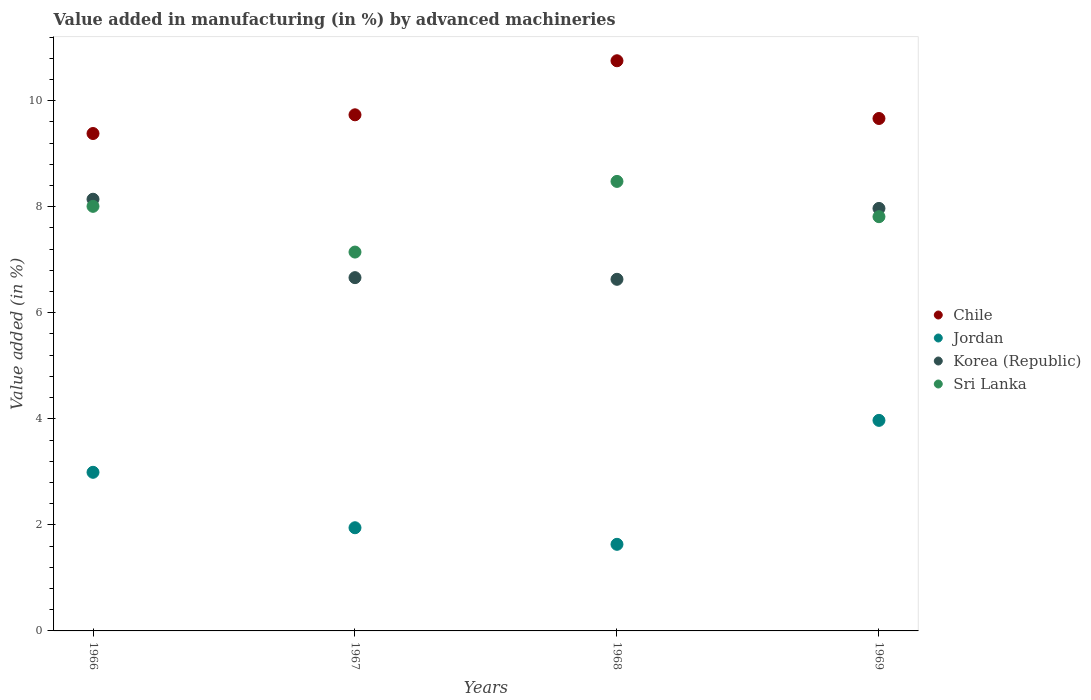Is the number of dotlines equal to the number of legend labels?
Provide a succinct answer. Yes. What is the percentage of value added in manufacturing by advanced machineries in Sri Lanka in 1967?
Provide a succinct answer. 7.14. Across all years, what is the maximum percentage of value added in manufacturing by advanced machineries in Korea (Republic)?
Your answer should be very brief. 8.14. Across all years, what is the minimum percentage of value added in manufacturing by advanced machineries in Korea (Republic)?
Your response must be concise. 6.63. In which year was the percentage of value added in manufacturing by advanced machineries in Chile maximum?
Ensure brevity in your answer.  1968. In which year was the percentage of value added in manufacturing by advanced machineries in Sri Lanka minimum?
Keep it short and to the point. 1967. What is the total percentage of value added in manufacturing by advanced machineries in Chile in the graph?
Provide a short and direct response. 39.53. What is the difference between the percentage of value added in manufacturing by advanced machineries in Sri Lanka in 1966 and that in 1968?
Provide a succinct answer. -0.47. What is the difference between the percentage of value added in manufacturing by advanced machineries in Jordan in 1967 and the percentage of value added in manufacturing by advanced machineries in Sri Lanka in 1968?
Keep it short and to the point. -6.53. What is the average percentage of value added in manufacturing by advanced machineries in Korea (Republic) per year?
Offer a terse response. 7.35. In the year 1967, what is the difference between the percentage of value added in manufacturing by advanced machineries in Jordan and percentage of value added in manufacturing by advanced machineries in Sri Lanka?
Provide a succinct answer. -5.2. In how many years, is the percentage of value added in manufacturing by advanced machineries in Chile greater than 4 %?
Offer a terse response. 4. What is the ratio of the percentage of value added in manufacturing by advanced machineries in Korea (Republic) in 1967 to that in 1968?
Keep it short and to the point. 1. Is the percentage of value added in manufacturing by advanced machineries in Sri Lanka in 1967 less than that in 1969?
Your answer should be compact. Yes. What is the difference between the highest and the second highest percentage of value added in manufacturing by advanced machineries in Jordan?
Your response must be concise. 0.98. What is the difference between the highest and the lowest percentage of value added in manufacturing by advanced machineries in Chile?
Ensure brevity in your answer.  1.37. Is it the case that in every year, the sum of the percentage of value added in manufacturing by advanced machineries in Sri Lanka and percentage of value added in manufacturing by advanced machineries in Chile  is greater than the percentage of value added in manufacturing by advanced machineries in Korea (Republic)?
Offer a terse response. Yes. Does the percentage of value added in manufacturing by advanced machineries in Jordan monotonically increase over the years?
Your answer should be very brief. No. Is the percentage of value added in manufacturing by advanced machineries in Jordan strictly greater than the percentage of value added in manufacturing by advanced machineries in Chile over the years?
Provide a succinct answer. No. How many years are there in the graph?
Ensure brevity in your answer.  4. What is the difference between two consecutive major ticks on the Y-axis?
Your answer should be very brief. 2. Are the values on the major ticks of Y-axis written in scientific E-notation?
Keep it short and to the point. No. Does the graph contain grids?
Your response must be concise. No. Where does the legend appear in the graph?
Your response must be concise. Center right. How many legend labels are there?
Offer a terse response. 4. What is the title of the graph?
Your answer should be very brief. Value added in manufacturing (in %) by advanced machineries. What is the label or title of the X-axis?
Offer a very short reply. Years. What is the label or title of the Y-axis?
Offer a very short reply. Value added (in %). What is the Value added (in %) in Chile in 1966?
Your answer should be compact. 9.38. What is the Value added (in %) in Jordan in 1966?
Give a very brief answer. 2.99. What is the Value added (in %) of Korea (Republic) in 1966?
Your answer should be very brief. 8.14. What is the Value added (in %) of Sri Lanka in 1966?
Make the answer very short. 8.01. What is the Value added (in %) in Chile in 1967?
Provide a short and direct response. 9.73. What is the Value added (in %) of Jordan in 1967?
Provide a short and direct response. 1.95. What is the Value added (in %) in Korea (Republic) in 1967?
Your response must be concise. 6.66. What is the Value added (in %) in Sri Lanka in 1967?
Provide a succinct answer. 7.14. What is the Value added (in %) of Chile in 1968?
Ensure brevity in your answer.  10.75. What is the Value added (in %) of Jordan in 1968?
Offer a terse response. 1.63. What is the Value added (in %) of Korea (Republic) in 1968?
Make the answer very short. 6.63. What is the Value added (in %) of Sri Lanka in 1968?
Offer a terse response. 8.48. What is the Value added (in %) in Chile in 1969?
Your answer should be very brief. 9.66. What is the Value added (in %) in Jordan in 1969?
Make the answer very short. 3.97. What is the Value added (in %) in Korea (Republic) in 1969?
Provide a short and direct response. 7.97. What is the Value added (in %) in Sri Lanka in 1969?
Provide a succinct answer. 7.81. Across all years, what is the maximum Value added (in %) of Chile?
Offer a very short reply. 10.75. Across all years, what is the maximum Value added (in %) in Jordan?
Make the answer very short. 3.97. Across all years, what is the maximum Value added (in %) in Korea (Republic)?
Keep it short and to the point. 8.14. Across all years, what is the maximum Value added (in %) in Sri Lanka?
Make the answer very short. 8.48. Across all years, what is the minimum Value added (in %) in Chile?
Offer a very short reply. 9.38. Across all years, what is the minimum Value added (in %) in Jordan?
Your answer should be compact. 1.63. Across all years, what is the minimum Value added (in %) of Korea (Republic)?
Offer a terse response. 6.63. Across all years, what is the minimum Value added (in %) in Sri Lanka?
Give a very brief answer. 7.14. What is the total Value added (in %) of Chile in the graph?
Your response must be concise. 39.53. What is the total Value added (in %) of Jordan in the graph?
Ensure brevity in your answer.  10.54. What is the total Value added (in %) of Korea (Republic) in the graph?
Offer a terse response. 29.4. What is the total Value added (in %) in Sri Lanka in the graph?
Your answer should be compact. 31.44. What is the difference between the Value added (in %) in Chile in 1966 and that in 1967?
Provide a short and direct response. -0.35. What is the difference between the Value added (in %) in Jordan in 1966 and that in 1967?
Offer a terse response. 1.05. What is the difference between the Value added (in %) in Korea (Republic) in 1966 and that in 1967?
Offer a terse response. 1.48. What is the difference between the Value added (in %) in Sri Lanka in 1966 and that in 1967?
Offer a very short reply. 0.86. What is the difference between the Value added (in %) of Chile in 1966 and that in 1968?
Provide a succinct answer. -1.37. What is the difference between the Value added (in %) of Jordan in 1966 and that in 1968?
Your answer should be very brief. 1.36. What is the difference between the Value added (in %) in Korea (Republic) in 1966 and that in 1968?
Make the answer very short. 1.51. What is the difference between the Value added (in %) in Sri Lanka in 1966 and that in 1968?
Give a very brief answer. -0.47. What is the difference between the Value added (in %) in Chile in 1966 and that in 1969?
Offer a very short reply. -0.28. What is the difference between the Value added (in %) of Jordan in 1966 and that in 1969?
Your response must be concise. -0.98. What is the difference between the Value added (in %) in Korea (Republic) in 1966 and that in 1969?
Ensure brevity in your answer.  0.17. What is the difference between the Value added (in %) of Sri Lanka in 1966 and that in 1969?
Offer a very short reply. 0.19. What is the difference between the Value added (in %) in Chile in 1967 and that in 1968?
Offer a very short reply. -1.02. What is the difference between the Value added (in %) in Jordan in 1967 and that in 1968?
Offer a very short reply. 0.31. What is the difference between the Value added (in %) in Korea (Republic) in 1967 and that in 1968?
Give a very brief answer. 0.03. What is the difference between the Value added (in %) in Sri Lanka in 1967 and that in 1968?
Your answer should be compact. -1.33. What is the difference between the Value added (in %) in Chile in 1967 and that in 1969?
Give a very brief answer. 0.07. What is the difference between the Value added (in %) of Jordan in 1967 and that in 1969?
Provide a succinct answer. -2.02. What is the difference between the Value added (in %) in Korea (Republic) in 1967 and that in 1969?
Offer a very short reply. -1.31. What is the difference between the Value added (in %) in Sri Lanka in 1967 and that in 1969?
Keep it short and to the point. -0.67. What is the difference between the Value added (in %) of Chile in 1968 and that in 1969?
Keep it short and to the point. 1.09. What is the difference between the Value added (in %) in Jordan in 1968 and that in 1969?
Your answer should be compact. -2.34. What is the difference between the Value added (in %) in Korea (Republic) in 1968 and that in 1969?
Ensure brevity in your answer.  -1.34. What is the difference between the Value added (in %) in Sri Lanka in 1968 and that in 1969?
Ensure brevity in your answer.  0.67. What is the difference between the Value added (in %) of Chile in 1966 and the Value added (in %) of Jordan in 1967?
Provide a succinct answer. 7.43. What is the difference between the Value added (in %) of Chile in 1966 and the Value added (in %) of Korea (Republic) in 1967?
Ensure brevity in your answer.  2.72. What is the difference between the Value added (in %) of Chile in 1966 and the Value added (in %) of Sri Lanka in 1967?
Provide a succinct answer. 2.24. What is the difference between the Value added (in %) of Jordan in 1966 and the Value added (in %) of Korea (Republic) in 1967?
Ensure brevity in your answer.  -3.67. What is the difference between the Value added (in %) of Jordan in 1966 and the Value added (in %) of Sri Lanka in 1967?
Your answer should be compact. -4.15. What is the difference between the Value added (in %) of Chile in 1966 and the Value added (in %) of Jordan in 1968?
Give a very brief answer. 7.75. What is the difference between the Value added (in %) of Chile in 1966 and the Value added (in %) of Korea (Republic) in 1968?
Give a very brief answer. 2.75. What is the difference between the Value added (in %) in Chile in 1966 and the Value added (in %) in Sri Lanka in 1968?
Ensure brevity in your answer.  0.9. What is the difference between the Value added (in %) in Jordan in 1966 and the Value added (in %) in Korea (Republic) in 1968?
Offer a very short reply. -3.64. What is the difference between the Value added (in %) in Jordan in 1966 and the Value added (in %) in Sri Lanka in 1968?
Provide a succinct answer. -5.49. What is the difference between the Value added (in %) of Korea (Republic) in 1966 and the Value added (in %) of Sri Lanka in 1968?
Provide a succinct answer. -0.34. What is the difference between the Value added (in %) of Chile in 1966 and the Value added (in %) of Jordan in 1969?
Offer a terse response. 5.41. What is the difference between the Value added (in %) of Chile in 1966 and the Value added (in %) of Korea (Republic) in 1969?
Give a very brief answer. 1.41. What is the difference between the Value added (in %) in Chile in 1966 and the Value added (in %) in Sri Lanka in 1969?
Ensure brevity in your answer.  1.57. What is the difference between the Value added (in %) in Jordan in 1966 and the Value added (in %) in Korea (Republic) in 1969?
Make the answer very short. -4.98. What is the difference between the Value added (in %) of Jordan in 1966 and the Value added (in %) of Sri Lanka in 1969?
Provide a short and direct response. -4.82. What is the difference between the Value added (in %) of Korea (Republic) in 1966 and the Value added (in %) of Sri Lanka in 1969?
Your response must be concise. 0.33. What is the difference between the Value added (in %) in Chile in 1967 and the Value added (in %) in Jordan in 1968?
Give a very brief answer. 8.1. What is the difference between the Value added (in %) in Chile in 1967 and the Value added (in %) in Korea (Republic) in 1968?
Keep it short and to the point. 3.1. What is the difference between the Value added (in %) of Chile in 1967 and the Value added (in %) of Sri Lanka in 1968?
Keep it short and to the point. 1.26. What is the difference between the Value added (in %) of Jordan in 1967 and the Value added (in %) of Korea (Republic) in 1968?
Offer a very short reply. -4.69. What is the difference between the Value added (in %) of Jordan in 1967 and the Value added (in %) of Sri Lanka in 1968?
Give a very brief answer. -6.53. What is the difference between the Value added (in %) in Korea (Republic) in 1967 and the Value added (in %) in Sri Lanka in 1968?
Give a very brief answer. -1.81. What is the difference between the Value added (in %) of Chile in 1967 and the Value added (in %) of Jordan in 1969?
Offer a terse response. 5.76. What is the difference between the Value added (in %) of Chile in 1967 and the Value added (in %) of Korea (Republic) in 1969?
Provide a succinct answer. 1.77. What is the difference between the Value added (in %) in Chile in 1967 and the Value added (in %) in Sri Lanka in 1969?
Your response must be concise. 1.92. What is the difference between the Value added (in %) in Jordan in 1967 and the Value added (in %) in Korea (Republic) in 1969?
Keep it short and to the point. -6.02. What is the difference between the Value added (in %) in Jordan in 1967 and the Value added (in %) in Sri Lanka in 1969?
Your answer should be very brief. -5.87. What is the difference between the Value added (in %) in Korea (Republic) in 1967 and the Value added (in %) in Sri Lanka in 1969?
Provide a succinct answer. -1.15. What is the difference between the Value added (in %) of Chile in 1968 and the Value added (in %) of Jordan in 1969?
Your response must be concise. 6.78. What is the difference between the Value added (in %) of Chile in 1968 and the Value added (in %) of Korea (Republic) in 1969?
Offer a very short reply. 2.78. What is the difference between the Value added (in %) of Chile in 1968 and the Value added (in %) of Sri Lanka in 1969?
Keep it short and to the point. 2.94. What is the difference between the Value added (in %) of Jordan in 1968 and the Value added (in %) of Korea (Republic) in 1969?
Offer a very short reply. -6.33. What is the difference between the Value added (in %) of Jordan in 1968 and the Value added (in %) of Sri Lanka in 1969?
Your response must be concise. -6.18. What is the difference between the Value added (in %) in Korea (Republic) in 1968 and the Value added (in %) in Sri Lanka in 1969?
Make the answer very short. -1.18. What is the average Value added (in %) in Chile per year?
Offer a very short reply. 9.88. What is the average Value added (in %) of Jordan per year?
Give a very brief answer. 2.64. What is the average Value added (in %) in Korea (Republic) per year?
Give a very brief answer. 7.35. What is the average Value added (in %) in Sri Lanka per year?
Ensure brevity in your answer.  7.86. In the year 1966, what is the difference between the Value added (in %) of Chile and Value added (in %) of Jordan?
Provide a short and direct response. 6.39. In the year 1966, what is the difference between the Value added (in %) of Chile and Value added (in %) of Korea (Republic)?
Give a very brief answer. 1.24. In the year 1966, what is the difference between the Value added (in %) in Chile and Value added (in %) in Sri Lanka?
Your response must be concise. 1.37. In the year 1966, what is the difference between the Value added (in %) of Jordan and Value added (in %) of Korea (Republic)?
Make the answer very short. -5.15. In the year 1966, what is the difference between the Value added (in %) in Jordan and Value added (in %) in Sri Lanka?
Give a very brief answer. -5.02. In the year 1966, what is the difference between the Value added (in %) in Korea (Republic) and Value added (in %) in Sri Lanka?
Provide a succinct answer. 0.13. In the year 1967, what is the difference between the Value added (in %) in Chile and Value added (in %) in Jordan?
Ensure brevity in your answer.  7.79. In the year 1967, what is the difference between the Value added (in %) of Chile and Value added (in %) of Korea (Republic)?
Give a very brief answer. 3.07. In the year 1967, what is the difference between the Value added (in %) of Chile and Value added (in %) of Sri Lanka?
Ensure brevity in your answer.  2.59. In the year 1967, what is the difference between the Value added (in %) in Jordan and Value added (in %) in Korea (Republic)?
Make the answer very short. -4.72. In the year 1967, what is the difference between the Value added (in %) in Jordan and Value added (in %) in Sri Lanka?
Provide a short and direct response. -5.2. In the year 1967, what is the difference between the Value added (in %) of Korea (Republic) and Value added (in %) of Sri Lanka?
Provide a short and direct response. -0.48. In the year 1968, what is the difference between the Value added (in %) in Chile and Value added (in %) in Jordan?
Offer a terse response. 9.12. In the year 1968, what is the difference between the Value added (in %) in Chile and Value added (in %) in Korea (Republic)?
Make the answer very short. 4.12. In the year 1968, what is the difference between the Value added (in %) of Chile and Value added (in %) of Sri Lanka?
Your answer should be compact. 2.28. In the year 1968, what is the difference between the Value added (in %) in Jordan and Value added (in %) in Korea (Republic)?
Your answer should be compact. -5. In the year 1968, what is the difference between the Value added (in %) in Jordan and Value added (in %) in Sri Lanka?
Your response must be concise. -6.84. In the year 1968, what is the difference between the Value added (in %) in Korea (Republic) and Value added (in %) in Sri Lanka?
Make the answer very short. -1.85. In the year 1969, what is the difference between the Value added (in %) in Chile and Value added (in %) in Jordan?
Your answer should be compact. 5.69. In the year 1969, what is the difference between the Value added (in %) in Chile and Value added (in %) in Korea (Republic)?
Keep it short and to the point. 1.7. In the year 1969, what is the difference between the Value added (in %) of Chile and Value added (in %) of Sri Lanka?
Give a very brief answer. 1.85. In the year 1969, what is the difference between the Value added (in %) of Jordan and Value added (in %) of Korea (Republic)?
Ensure brevity in your answer.  -4. In the year 1969, what is the difference between the Value added (in %) of Jordan and Value added (in %) of Sri Lanka?
Your answer should be compact. -3.84. In the year 1969, what is the difference between the Value added (in %) of Korea (Republic) and Value added (in %) of Sri Lanka?
Make the answer very short. 0.16. What is the ratio of the Value added (in %) of Chile in 1966 to that in 1967?
Your answer should be compact. 0.96. What is the ratio of the Value added (in %) of Jordan in 1966 to that in 1967?
Keep it short and to the point. 1.54. What is the ratio of the Value added (in %) of Korea (Republic) in 1966 to that in 1967?
Give a very brief answer. 1.22. What is the ratio of the Value added (in %) of Sri Lanka in 1966 to that in 1967?
Your answer should be very brief. 1.12. What is the ratio of the Value added (in %) in Chile in 1966 to that in 1968?
Keep it short and to the point. 0.87. What is the ratio of the Value added (in %) in Jordan in 1966 to that in 1968?
Offer a very short reply. 1.83. What is the ratio of the Value added (in %) of Korea (Republic) in 1966 to that in 1968?
Your answer should be very brief. 1.23. What is the ratio of the Value added (in %) of Sri Lanka in 1966 to that in 1968?
Your response must be concise. 0.94. What is the ratio of the Value added (in %) in Chile in 1966 to that in 1969?
Ensure brevity in your answer.  0.97. What is the ratio of the Value added (in %) of Jordan in 1966 to that in 1969?
Give a very brief answer. 0.75. What is the ratio of the Value added (in %) in Korea (Republic) in 1966 to that in 1969?
Offer a terse response. 1.02. What is the ratio of the Value added (in %) of Sri Lanka in 1966 to that in 1969?
Offer a very short reply. 1.02. What is the ratio of the Value added (in %) of Chile in 1967 to that in 1968?
Give a very brief answer. 0.91. What is the ratio of the Value added (in %) of Jordan in 1967 to that in 1968?
Offer a terse response. 1.19. What is the ratio of the Value added (in %) in Korea (Republic) in 1967 to that in 1968?
Provide a short and direct response. 1. What is the ratio of the Value added (in %) in Sri Lanka in 1967 to that in 1968?
Provide a short and direct response. 0.84. What is the ratio of the Value added (in %) of Jordan in 1967 to that in 1969?
Your answer should be compact. 0.49. What is the ratio of the Value added (in %) of Korea (Republic) in 1967 to that in 1969?
Offer a terse response. 0.84. What is the ratio of the Value added (in %) in Sri Lanka in 1967 to that in 1969?
Provide a succinct answer. 0.91. What is the ratio of the Value added (in %) in Chile in 1968 to that in 1969?
Offer a very short reply. 1.11. What is the ratio of the Value added (in %) of Jordan in 1968 to that in 1969?
Your response must be concise. 0.41. What is the ratio of the Value added (in %) of Korea (Republic) in 1968 to that in 1969?
Keep it short and to the point. 0.83. What is the ratio of the Value added (in %) in Sri Lanka in 1968 to that in 1969?
Give a very brief answer. 1.09. What is the difference between the highest and the second highest Value added (in %) of Chile?
Your response must be concise. 1.02. What is the difference between the highest and the second highest Value added (in %) in Jordan?
Give a very brief answer. 0.98. What is the difference between the highest and the second highest Value added (in %) in Korea (Republic)?
Provide a short and direct response. 0.17. What is the difference between the highest and the second highest Value added (in %) of Sri Lanka?
Keep it short and to the point. 0.47. What is the difference between the highest and the lowest Value added (in %) in Chile?
Offer a terse response. 1.37. What is the difference between the highest and the lowest Value added (in %) in Jordan?
Your answer should be very brief. 2.34. What is the difference between the highest and the lowest Value added (in %) in Korea (Republic)?
Offer a very short reply. 1.51. What is the difference between the highest and the lowest Value added (in %) of Sri Lanka?
Provide a short and direct response. 1.33. 